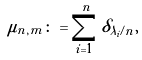Convert formula to latex. <formula><loc_0><loc_0><loc_500><loc_500>\mu _ { n , m } \colon = \sum _ { i = 1 } ^ { n } \delta _ { \lambda _ { i } \slash n } ,</formula> 